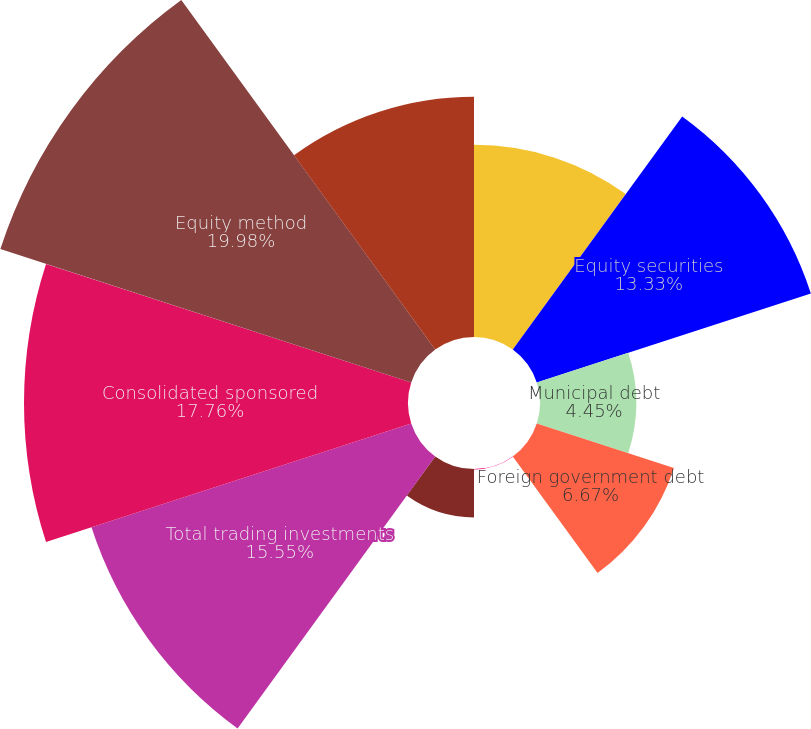Convert chart. <chart><loc_0><loc_0><loc_500><loc_500><pie_chart><fcel>fund investments<fcel>Equity securities<fcel>Municipal debt<fcel>Foreign government debt<fcel>Corporate debt<fcel>US government debt<fcel>Total trading investments<fcel>Consolidated sponsored<fcel>Equity method<fcel>Deferred compensation plan<nl><fcel>8.89%<fcel>13.33%<fcel>4.45%<fcel>6.67%<fcel>0.02%<fcel>2.24%<fcel>15.55%<fcel>17.76%<fcel>19.98%<fcel>11.11%<nl></chart> 